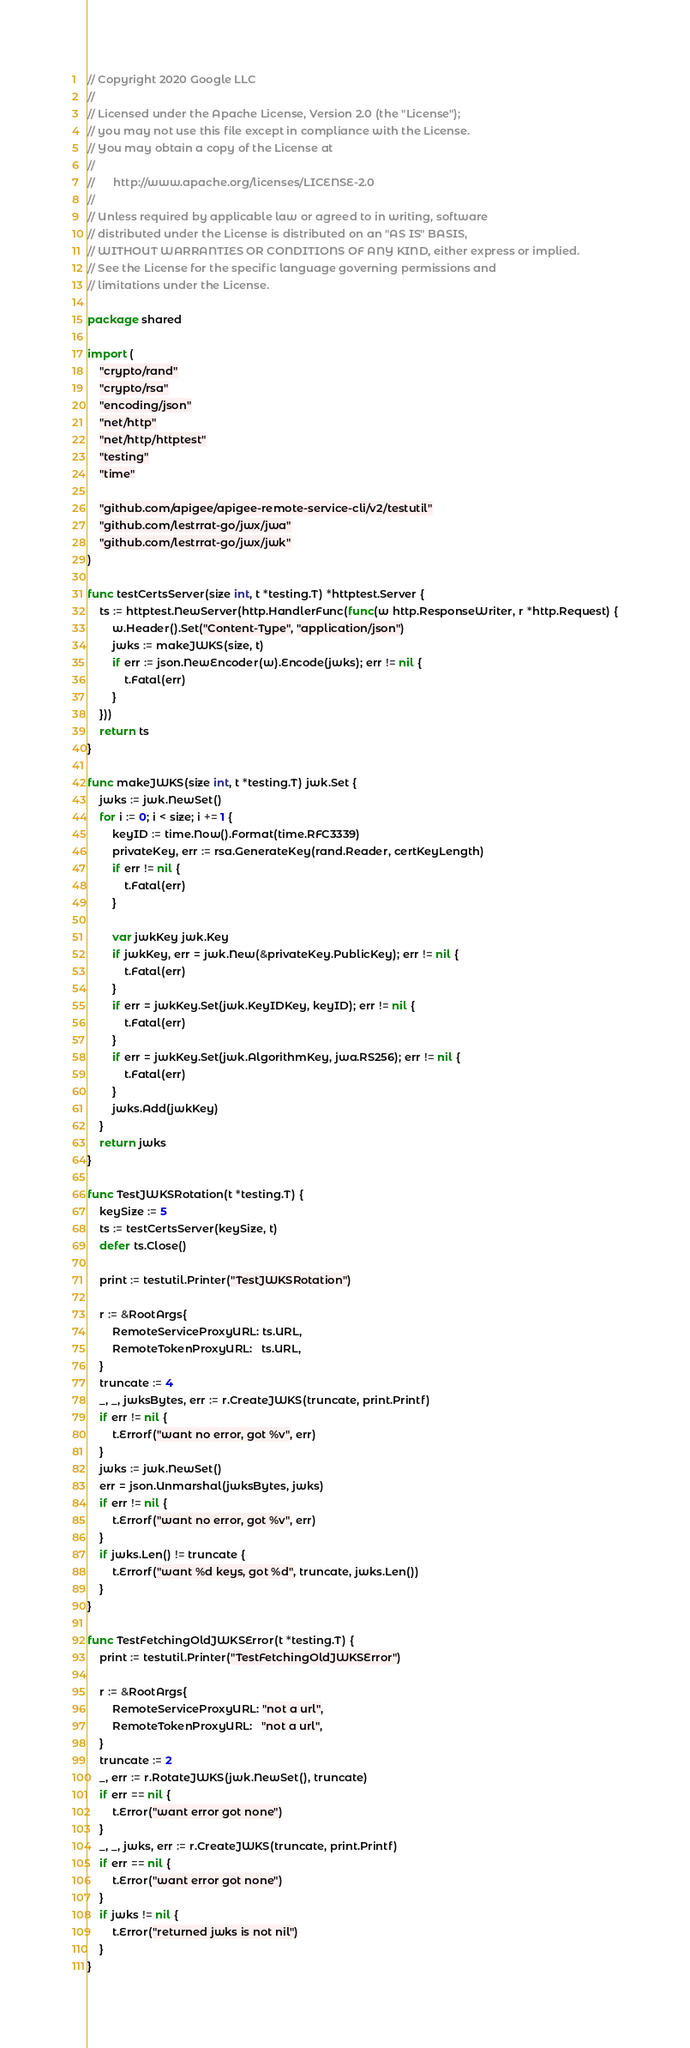<code> <loc_0><loc_0><loc_500><loc_500><_Go_>// Copyright 2020 Google LLC
//
// Licensed under the Apache License, Version 2.0 (the "License");
// you may not use this file except in compliance with the License.
// You may obtain a copy of the License at
//
//      http://www.apache.org/licenses/LICENSE-2.0
//
// Unless required by applicable law or agreed to in writing, software
// distributed under the License is distributed on an "AS IS" BASIS,
// WITHOUT WARRANTIES OR CONDITIONS OF ANY KIND, either express or implied.
// See the License for the specific language governing permissions and
// limitations under the License.

package shared

import (
	"crypto/rand"
	"crypto/rsa"
	"encoding/json"
	"net/http"
	"net/http/httptest"
	"testing"
	"time"

	"github.com/apigee/apigee-remote-service-cli/v2/testutil"
	"github.com/lestrrat-go/jwx/jwa"
	"github.com/lestrrat-go/jwx/jwk"
)

func testCertsServer(size int, t *testing.T) *httptest.Server {
	ts := httptest.NewServer(http.HandlerFunc(func(w http.ResponseWriter, r *http.Request) {
		w.Header().Set("Content-Type", "application/json")
		jwks := makeJWKS(size, t)
		if err := json.NewEncoder(w).Encode(jwks); err != nil {
			t.Fatal(err)
		}
	}))
	return ts
}

func makeJWKS(size int, t *testing.T) jwk.Set {
	jwks := jwk.NewSet()
	for i := 0; i < size; i += 1 {
		keyID := time.Now().Format(time.RFC3339)
		privateKey, err := rsa.GenerateKey(rand.Reader, certKeyLength)
		if err != nil {
			t.Fatal(err)
		}

		var jwkKey jwk.Key
		if jwkKey, err = jwk.New(&privateKey.PublicKey); err != nil {
			t.Fatal(err)
		}
		if err = jwkKey.Set(jwk.KeyIDKey, keyID); err != nil {
			t.Fatal(err)
		}
		if err = jwkKey.Set(jwk.AlgorithmKey, jwa.RS256); err != nil {
			t.Fatal(err)
		}
		jwks.Add(jwkKey)
	}
	return jwks
}

func TestJWKSRotation(t *testing.T) {
	keySize := 5
	ts := testCertsServer(keySize, t)
	defer ts.Close()

	print := testutil.Printer("TestJWKSRotation")

	r := &RootArgs{
		RemoteServiceProxyURL: ts.URL,
		RemoteTokenProxyURL:   ts.URL,
	}
	truncate := 4
	_, _, jwksBytes, err := r.CreateJWKS(truncate, print.Printf)
	if err != nil {
		t.Errorf("want no error, got %v", err)
	}
	jwks := jwk.NewSet()
	err = json.Unmarshal(jwksBytes, jwks)
	if err != nil {
		t.Errorf("want no error, got %v", err)
	}
	if jwks.Len() != truncate {
		t.Errorf("want %d keys, got %d", truncate, jwks.Len())
	}
}

func TestFetchingOldJWKSError(t *testing.T) {
	print := testutil.Printer("TestFetchingOldJWKSError")

	r := &RootArgs{
		RemoteServiceProxyURL: "not a url",
		RemoteTokenProxyURL:   "not a url",
	}
	truncate := 2
	_, err := r.RotateJWKS(jwk.NewSet(), truncate)
	if err == nil {
		t.Error("want error got none")
	}
	_, _, jwks, err := r.CreateJWKS(truncate, print.Printf)
	if err == nil {
		t.Error("want error got none")
	}
	if jwks != nil {
		t.Error("returned jwks is not nil")
	}
}
</code> 